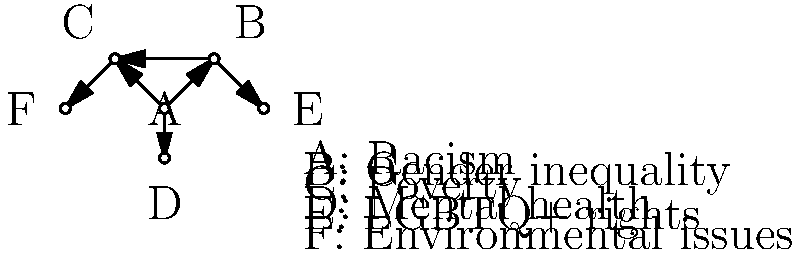Given the network diagram representing the interconnected social issues in a primetime drama series, calculate the out-degree centrality for node A (Racism). How does this value reflect the drama's emphasis on racism as a central theme, and what implications might this have for audience perception of social issues? To answer this question, we need to follow these steps:

1. Understand out-degree centrality:
   Out-degree centrality is the number of outgoing connections from a node in a directed graph.

2. Count the outgoing connections from node A (Racism):
   Node A has three outgoing connections: to B (Gender inequality), C (Poverty), and D (Mental health).

3. Calculate the out-degree centrality:
   The out-degree centrality for node A is 3.

4. Interpret the result:
   - A high out-degree centrality (3 out of 5 possible connections) suggests that racism is a central theme in the drama.
   - It indicates that the show frequently connects racism to other social issues, demonstrating its pervasive nature.

5. Consider implications for audience perception:
   - The high centrality of racism may lead viewers to see it as a root cause of other social problems.
   - It could increase audience awareness of how racism intersects with other issues like gender inequality, poverty, and mental health.
   - The drama's emphasis on racism might prompt viewers to reflect on its impact in their own lives and society at large.
   - However, the focus on racism might overshadow other important social issues that have fewer connections in the network.

6. Reflect on the limitations:
   - This analysis is based solely on the number of connections and doesn't account for the depth or quality of treatment each issue receives in the drama.
   - The impact on audience perception would also depend on factors like storyline quality, character development, and overall execution of the themes.
Answer: Out-degree centrality: 3. Implies racism as a central, interconnected theme, potentially increasing audience awareness of its pervasiveness and relationship to other social issues. 